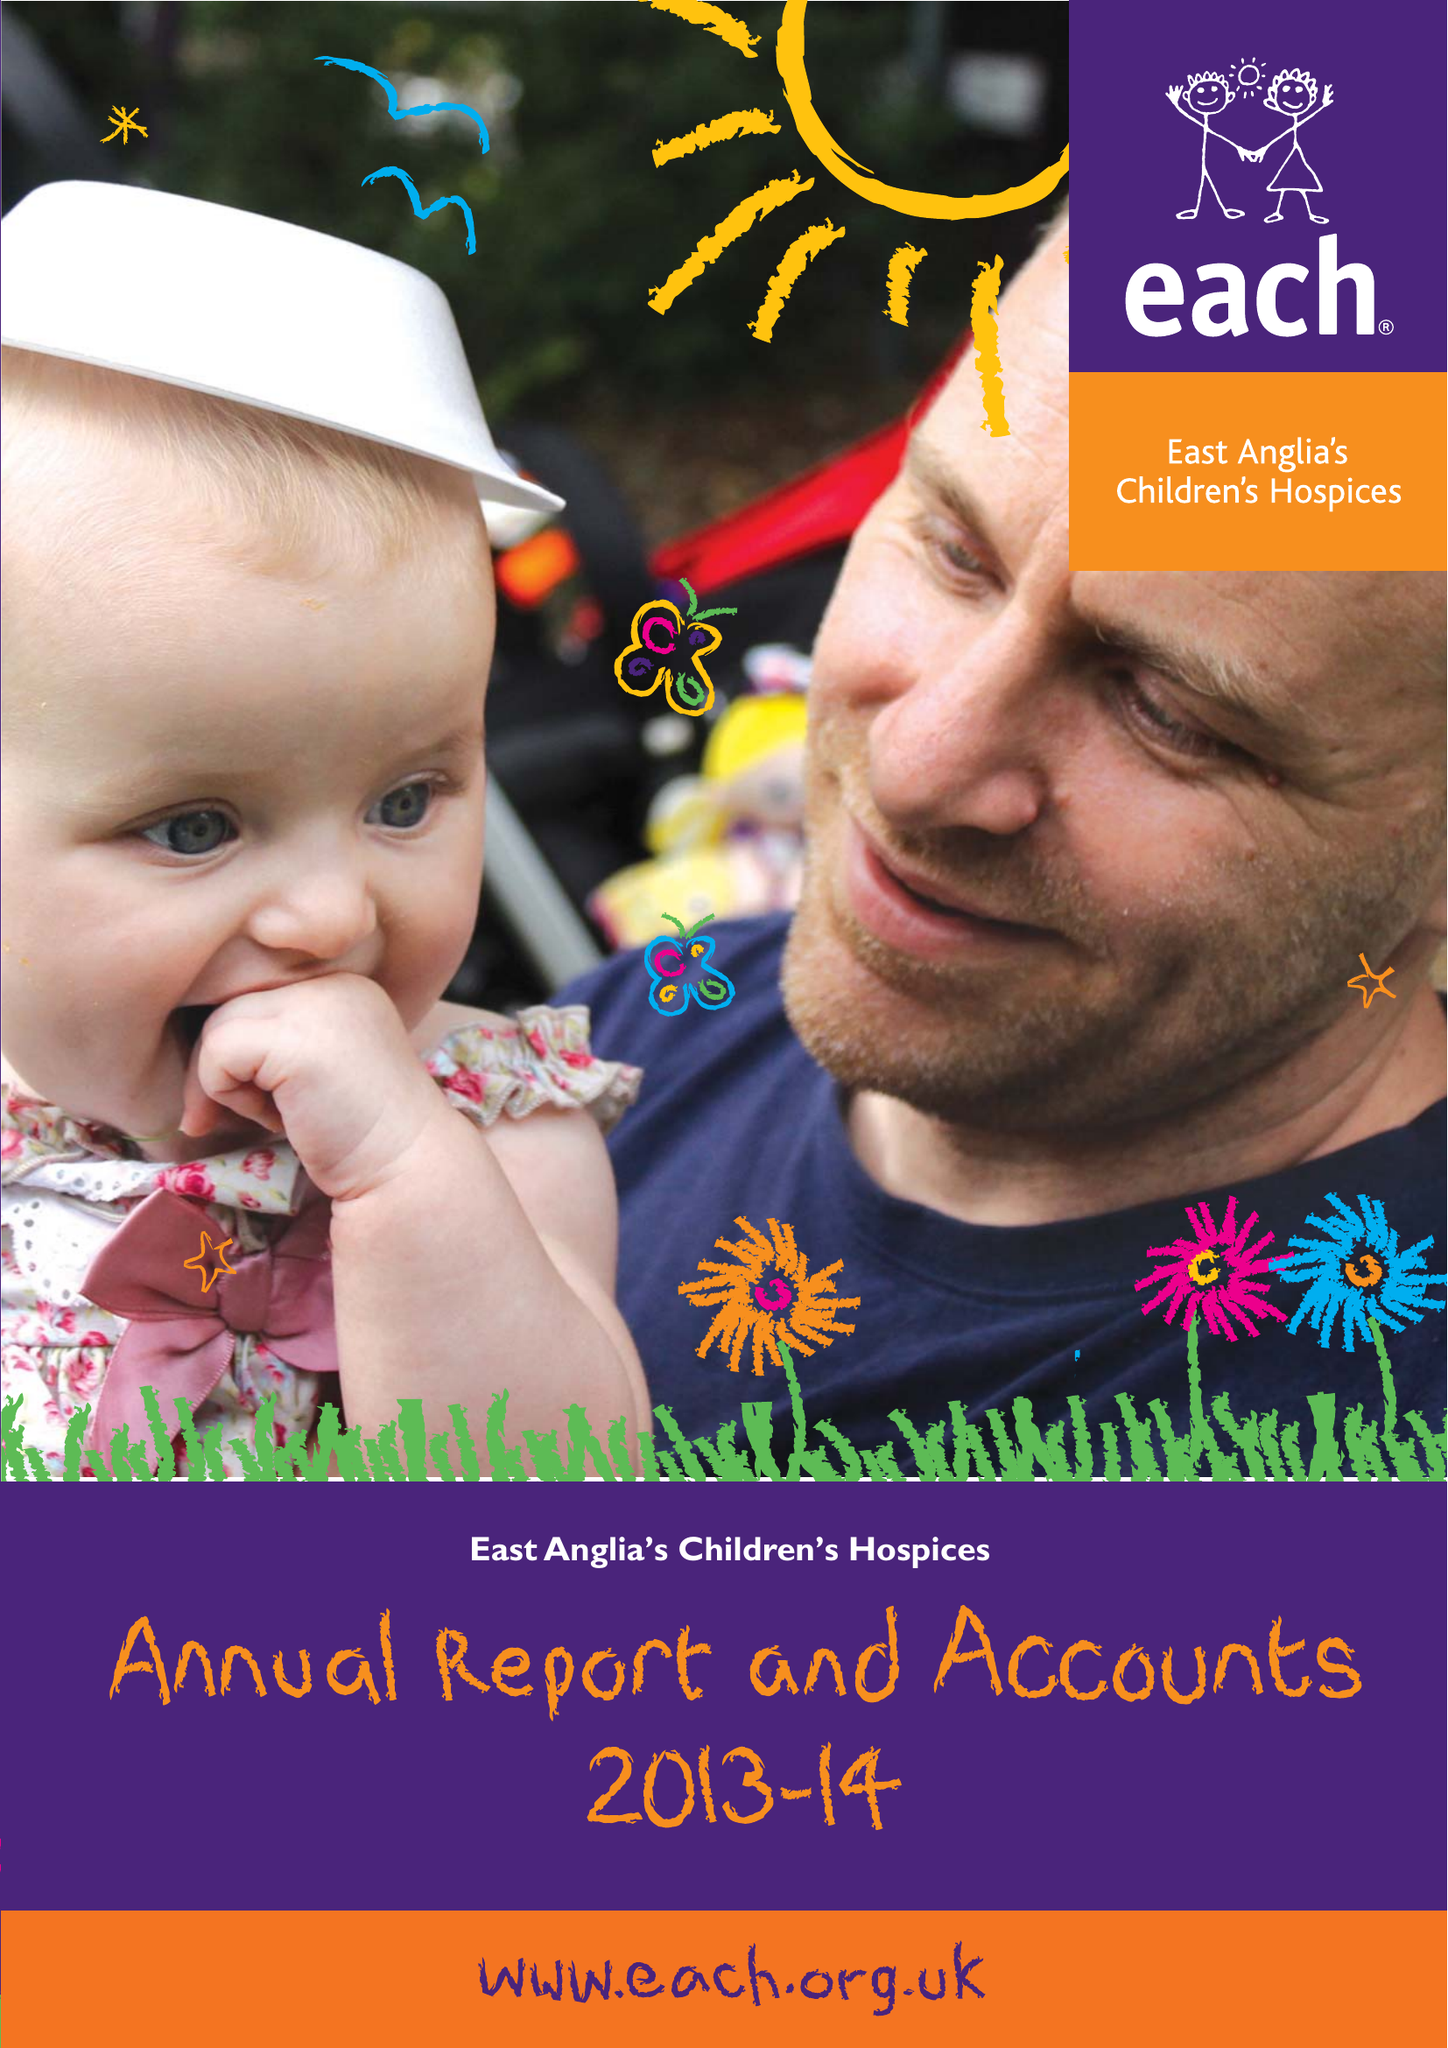What is the value for the address__post_town?
Answer the question using a single word or phrase. CAMBRIDGE 